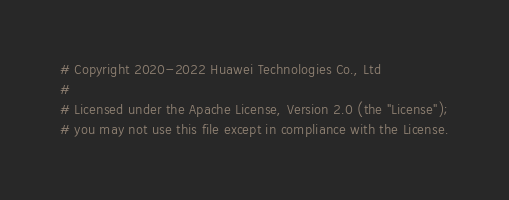<code> <loc_0><loc_0><loc_500><loc_500><_Python_># Copyright 2020-2022 Huawei Technologies Co., Ltd
#
# Licensed under the Apache License, Version 2.0 (the "License");
# you may not use this file except in compliance with the License.</code> 